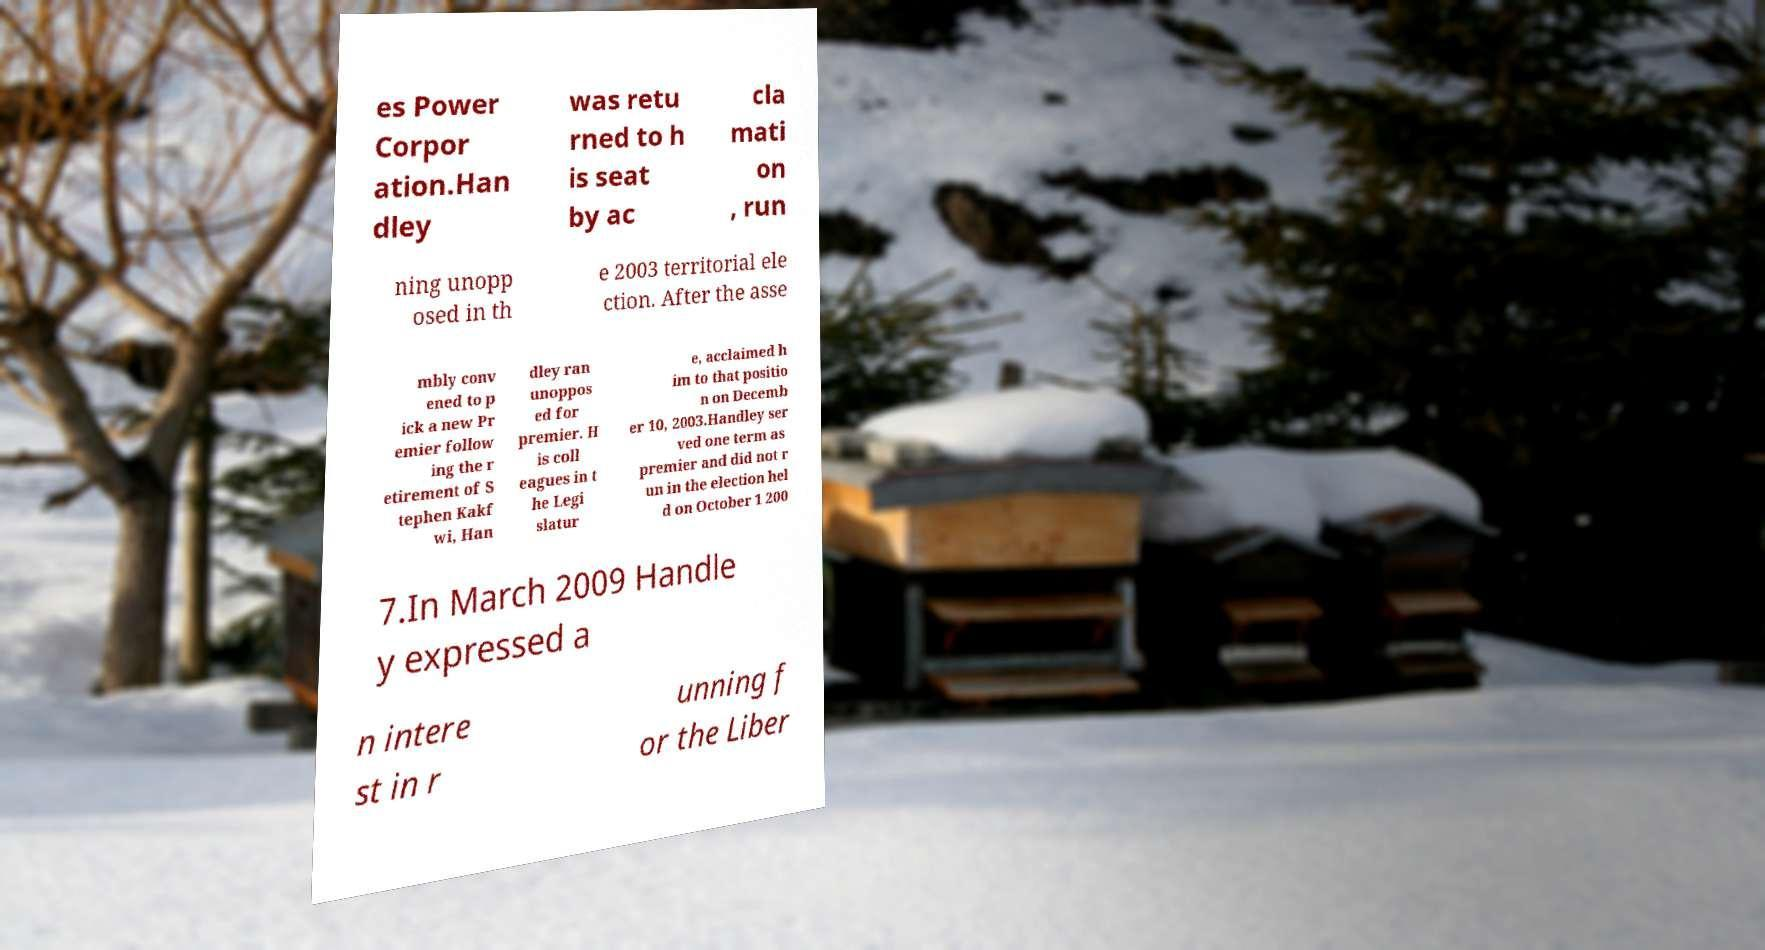Could you extract and type out the text from this image? es Power Corpor ation.Han dley was retu rned to h is seat by ac cla mati on , run ning unopp osed in th e 2003 territorial ele ction. After the asse mbly conv ened to p ick a new Pr emier follow ing the r etirement of S tephen Kakf wi, Han dley ran unoppos ed for premier. H is coll eagues in t he Legi slatur e, acclaimed h im to that positio n on Decemb er 10, 2003.Handley ser ved one term as premier and did not r un in the election hel d on October 1 200 7.In March 2009 Handle y expressed a n intere st in r unning f or the Liber 